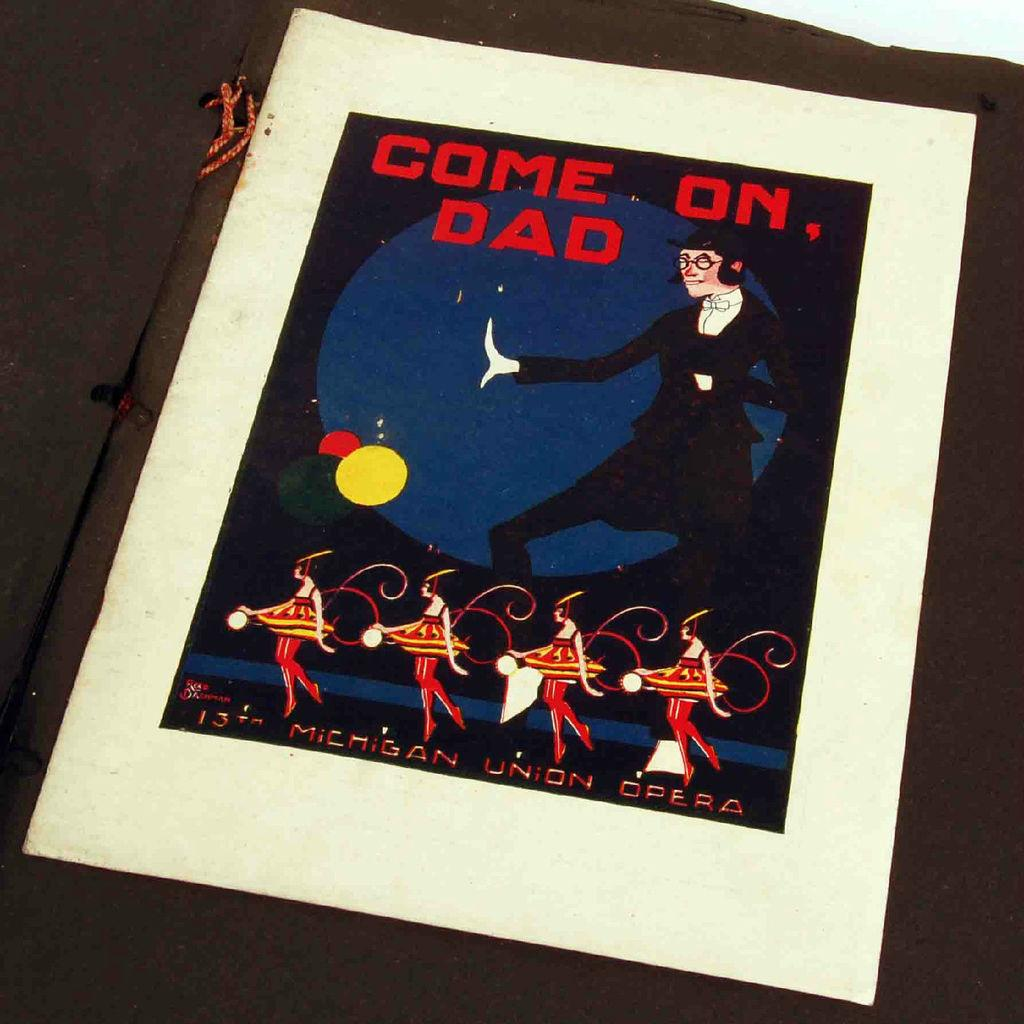What is featured on the poster in the image? There is a poster in the image, and it has the text "come on dad". Who or what is depicted on the poster? A man is depicted on the poster. What are the four ladies doing at the bottom of the poster? The four ladies are dancing at the bottom of the poster. How many kittens are playing with the waves in the image? There are no kittens or waves present in the image. 